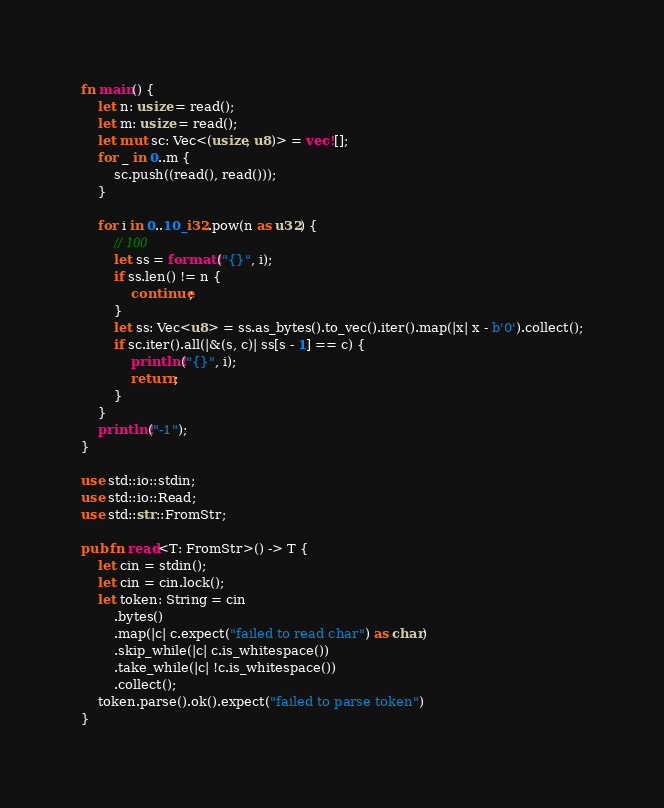Convert code to text. <code><loc_0><loc_0><loc_500><loc_500><_Rust_>fn main() {
    let n: usize = read();
    let m: usize = read();
    let mut sc: Vec<(usize, u8)> = vec![];
    for _ in 0..m {
        sc.push((read(), read()));
    }

    for i in 0..10_i32.pow(n as u32) {
        // 100
        let ss = format!("{}", i);
        if ss.len() != n {
            continue;
        }
        let ss: Vec<u8> = ss.as_bytes().to_vec().iter().map(|x| x - b'0').collect();
        if sc.iter().all(|&(s, c)| ss[s - 1] == c) {
            println!("{}", i);
            return;
        }
    }
    println!("-1");
}

use std::io::stdin;
use std::io::Read;
use std::str::FromStr;

pub fn read<T: FromStr>() -> T {
    let cin = stdin();
    let cin = cin.lock();
    let token: String = cin
        .bytes()
        .map(|c| c.expect("failed to read char") as char)
        .skip_while(|c| c.is_whitespace())
        .take_while(|c| !c.is_whitespace())
        .collect();
    token.parse().ok().expect("failed to parse token")
}
</code> 